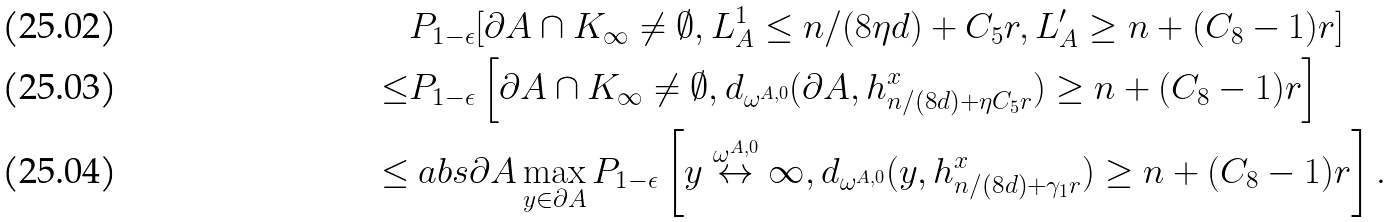<formula> <loc_0><loc_0><loc_500><loc_500>& { P } _ { 1 - \epsilon } [ \partial A \cap K _ { \infty } \neq \emptyset , L _ { A } ^ { 1 } \leq n / ( 8 \eta d ) + C _ { 5 } r , L _ { A } ^ { \prime } \geq n + ( C _ { 8 } - 1 ) r ] \\ \leq & { P } _ { 1 - \epsilon } \left [ \partial A \cap K _ { \infty } \neq \emptyset , d _ { \omega ^ { A , 0 } } ( \partial A , h _ { n / ( 8 d ) + \eta C _ { 5 } r } ^ { x } ) \geq n + ( C _ { 8 } - 1 ) r \right ] \\ \leq & \ a b s { \partial A } \max _ { y \in \partial A } { P } _ { 1 - \epsilon } \left [ y \stackrel { \omega ^ { A , 0 } } { \leftrightarrow } \infty , d _ { \omega ^ { A , 0 } } ( y , h _ { n / ( 8 d ) + \gamma _ { 1 } r } ^ { x } ) \geq n + ( C _ { 8 } - 1 ) r \right ] .</formula> 